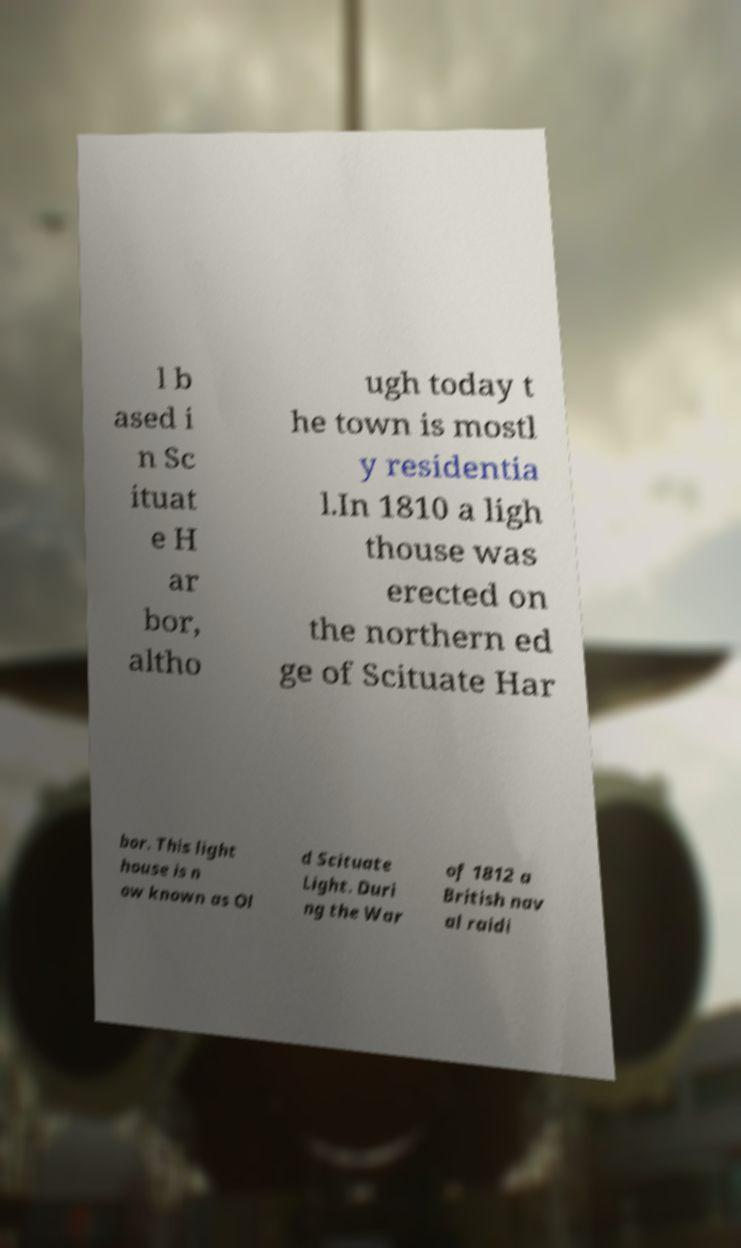Please identify and transcribe the text found in this image. l b ased i n Sc ituat e H ar bor, altho ugh today t he town is mostl y residentia l.In 1810 a ligh thouse was erected on the northern ed ge of Scituate Har bor. This light house is n ow known as Ol d Scituate Light. Duri ng the War of 1812 a British nav al raidi 